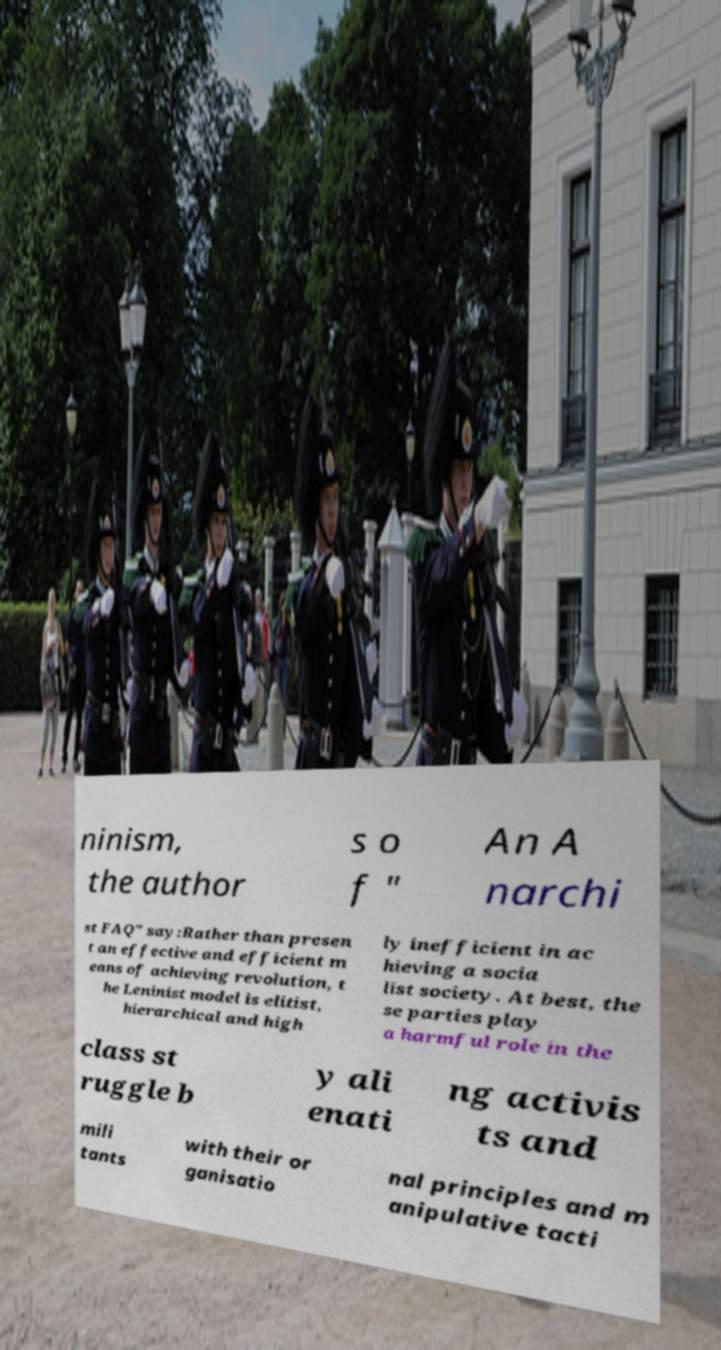Please read and relay the text visible in this image. What does it say? ninism, the author s o f " An A narchi st FAQ" say:Rather than presen t an effective and efficient m eans of achieving revolution, t he Leninist model is elitist, hierarchical and high ly inefficient in ac hieving a socia list society. At best, the se parties play a harmful role in the class st ruggle b y ali enati ng activis ts and mili tants with their or ganisatio nal principles and m anipulative tacti 